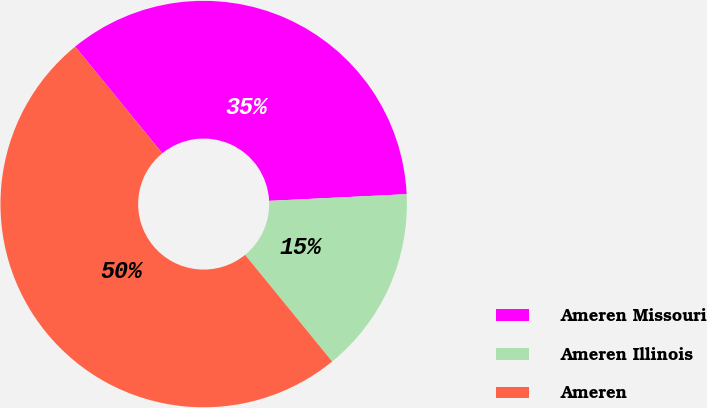<chart> <loc_0><loc_0><loc_500><loc_500><pie_chart><fcel>Ameren Missouri<fcel>Ameren Illinois<fcel>Ameren<nl><fcel>35.12%<fcel>14.88%<fcel>50.0%<nl></chart> 